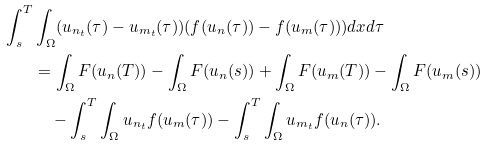<formula> <loc_0><loc_0><loc_500><loc_500>\int _ { s } ^ { T } & \int _ { \Omega } ( u _ { n _ { t } } ( \tau ) - u _ { m _ { t } } ( \tau ) ) ( f ( u _ { n } ( \tau ) ) - f ( u _ { m } ( \tau ) ) ) d x d \tau \\ & = \int _ { \Omega } F ( u _ { n } ( T ) ) - \int _ { \Omega } F ( u _ { n } ( s ) ) + \int _ { \Omega } F ( u _ { m } ( T ) ) - \int _ { \Omega } F ( u _ { m } ( s ) ) \\ & \quad - \int _ { s } ^ { T } \int _ { \Omega } u _ { n _ { t } } f ( u _ { m } ( \tau ) ) - \int _ { s } ^ { T } \int _ { \Omega } u _ { m _ { t } } f ( u _ { n } ( \tau ) ) .</formula> 